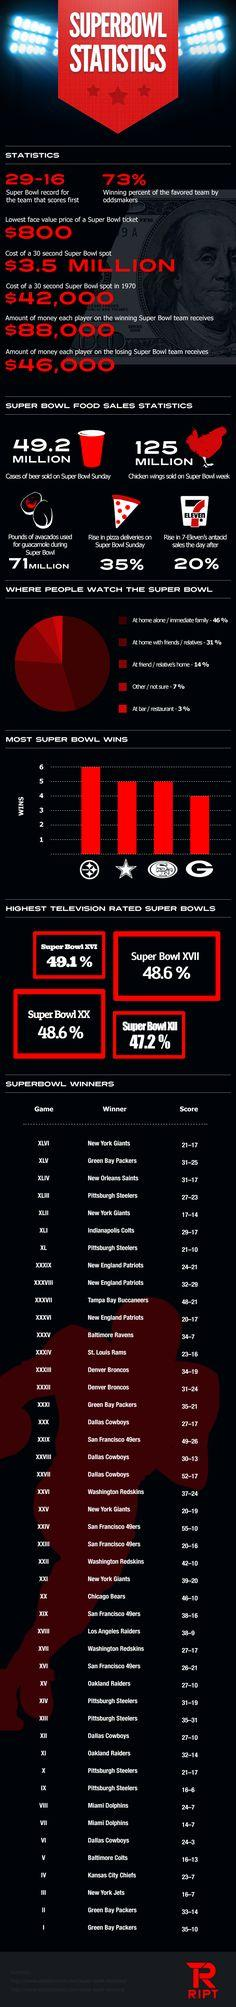Draw attention to some important aspects in this diagram. In Super Bowl XLV, the Green Bay Packers emerged as the champions, defeating the Pittsburgh Steelers to claim the title. Super Bowl XLII was won by the New York Giants with a final score of 17-14, cementing their victory over the New England Patriots in an exciting and closely contested match. The Super Bowl XX television rating was 48.6%. The Oakland Raiders won Super Bowl XV. The Super Bowl XVII television rating was 48.6%. 